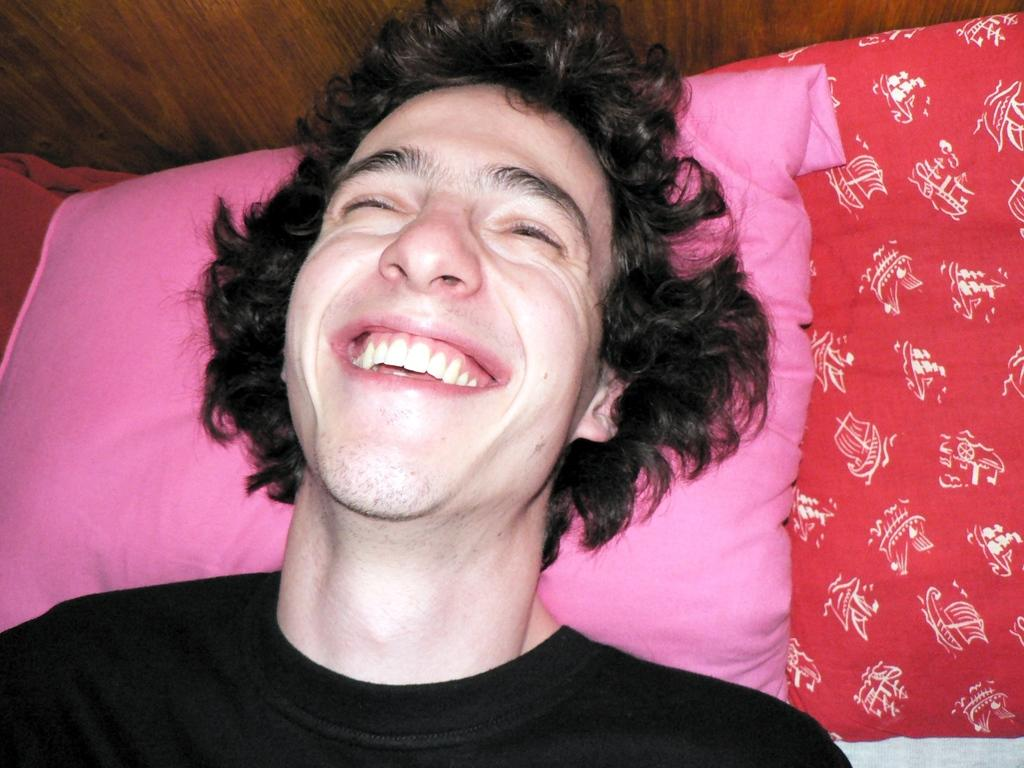What is the person in the image doing? The person is lying on the bed. What expression does the person have? The person is smiling. What color is the t-shirt the person is wearing? The person is wearing a black t-shirt. What colors are the pillows on the bed? The pillows on the bed are pink and red. What type of material is visible in the background? The background is made of wood. What type of notebook is the person holding in the image? There is no notebook present in the image. What emotion is the person displaying in the image? The person is displaying happiness, as they are smiling. 